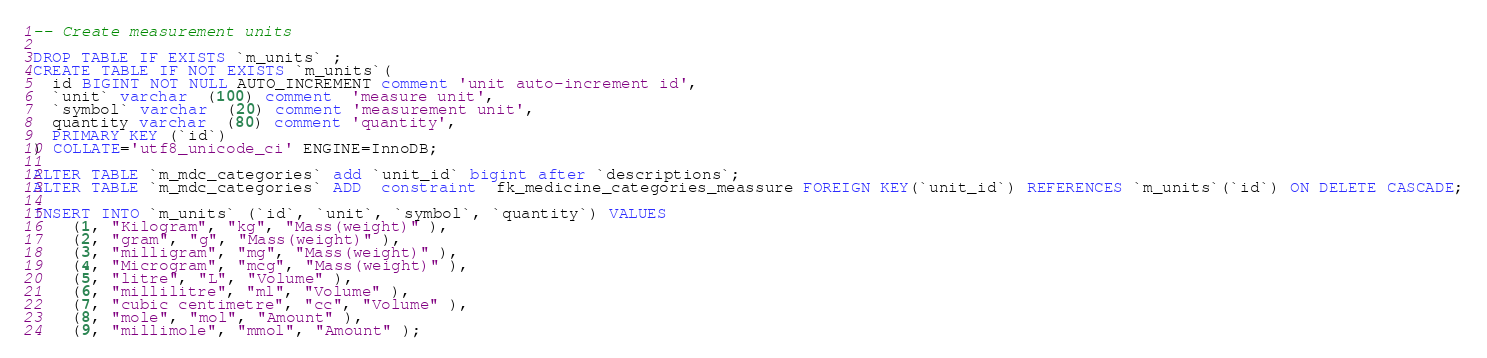<code> <loc_0><loc_0><loc_500><loc_500><_SQL_>-- Create measurement units

DROP TABLE IF EXISTS `m_units` ;
CREATE TABLE IF NOT EXISTS `m_units`(
  id BIGINT NOT NULL AUTO_INCREMENT comment 'unit auto-increment id',
  `unit` varchar  (100) comment  'measure unit',
  `symbol` varchar  (20) comment 'measurement unit',
  quantity varchar  (80) comment 'quantity',
  PRIMARY KEY (`id`)
) COLLATE='utf8_unicode_ci' ENGINE=InnoDB;

ALTER TABLE `m_mdc_categories` add `unit_id` bigint after `descriptions`;
ALTER TABLE `m_mdc_categories` ADD  constraint  fk_medicine_categories_meassure FOREIGN KEY(`unit_id`) REFERENCES `m_units`(`id`) ON DELETE CASCADE;

INSERT INTO `m_units` (`id`, `unit`, `symbol`, `quantity`) VALUES
    (1, "Kilogram", "kg", "Mass(weight)" ),
    (2, "gram", "g", "Mass(weight)" ),
    (3, "milligram", "mg", "Mass(weight)" ),
    (4, "Microgram", "mcg", "Mass(weight)" ),
    (5, "litre", "L", "Volume" ),
    (6, "millilitre", "ml", "Volume" ),
    (7, "cubic centimetre", "cc", "Volume" ),
    (8, "mole", "mol", "Amount" ),
    (9, "millimole", "mmol", "Amount" );


</code> 